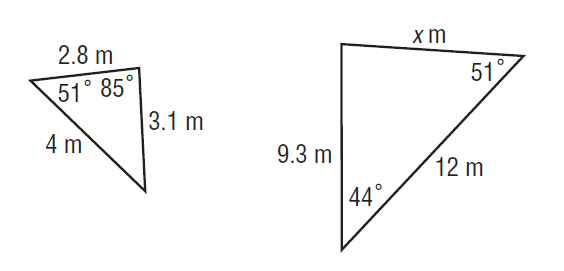Answer the mathemtical geometry problem and directly provide the correct option letter.
Question: Find x.
Choices: A: 4.2 B: 4.65 C: 5.6 D: 8.4 D 